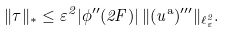<formula> <loc_0><loc_0><loc_500><loc_500>\| \tau \| _ { * } \leq \varepsilon ^ { 2 } | \phi ^ { \prime \prime } ( 2 F ) | \, \| ( u ^ { \text {a} } ) ^ { \prime \prime \prime } \| _ { \ell _ { \varepsilon } ^ { 2 } } .</formula> 